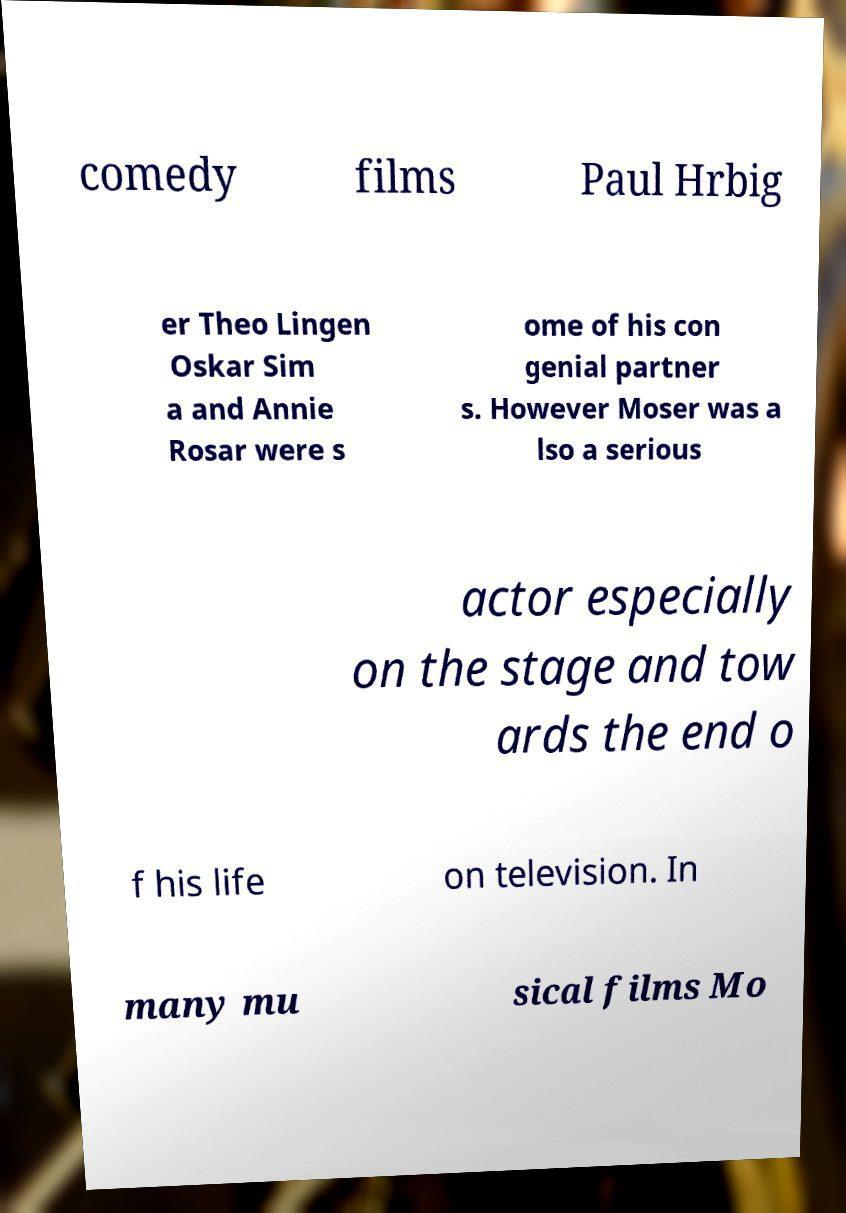I need the written content from this picture converted into text. Can you do that? comedy films Paul Hrbig er Theo Lingen Oskar Sim a and Annie Rosar were s ome of his con genial partner s. However Moser was a lso a serious actor especially on the stage and tow ards the end o f his life on television. In many mu sical films Mo 